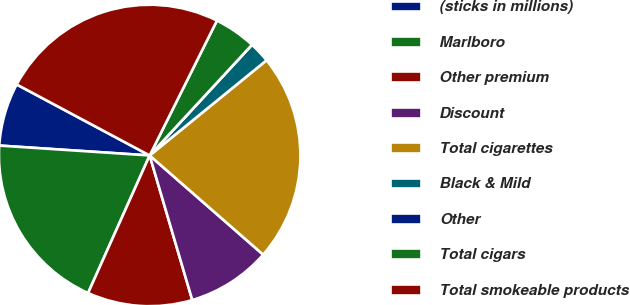Convert chart. <chart><loc_0><loc_0><loc_500><loc_500><pie_chart><fcel>(sticks in millions)<fcel>Marlboro<fcel>Other premium<fcel>Discount<fcel>Total cigarettes<fcel>Black & Mild<fcel>Other<fcel>Total cigars<fcel>Total smokeable products<nl><fcel>6.76%<fcel>19.35%<fcel>11.26%<fcel>9.01%<fcel>22.31%<fcel>2.25%<fcel>0.0%<fcel>4.51%<fcel>24.56%<nl></chart> 